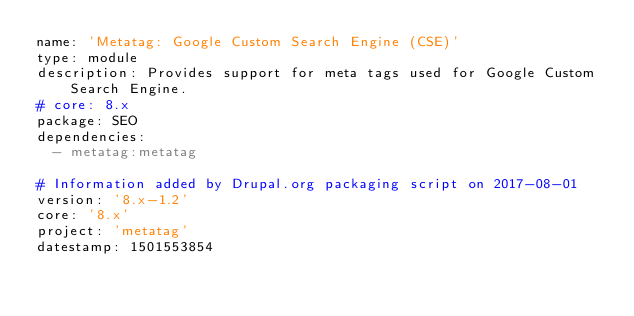Convert code to text. <code><loc_0><loc_0><loc_500><loc_500><_YAML_>name: 'Metatag: Google Custom Search Engine (CSE)'
type: module
description: Provides support for meta tags used for Google Custom Search Engine.
# core: 8.x
package: SEO
dependencies:
  - metatag:metatag

# Information added by Drupal.org packaging script on 2017-08-01
version: '8.x-1.2'
core: '8.x'
project: 'metatag'
datestamp: 1501553854
</code> 